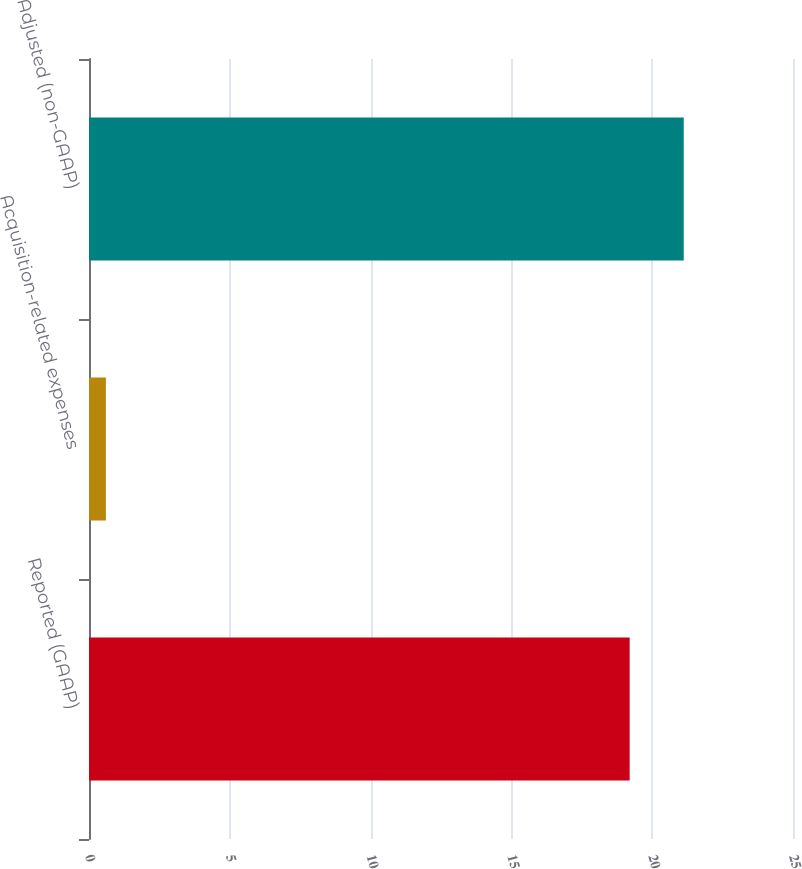Convert chart. <chart><loc_0><loc_0><loc_500><loc_500><bar_chart><fcel>Reported (GAAP)<fcel>Acquisition-related expenses<fcel>Adjusted (non-GAAP)<nl><fcel>19.2<fcel>0.6<fcel>21.12<nl></chart> 